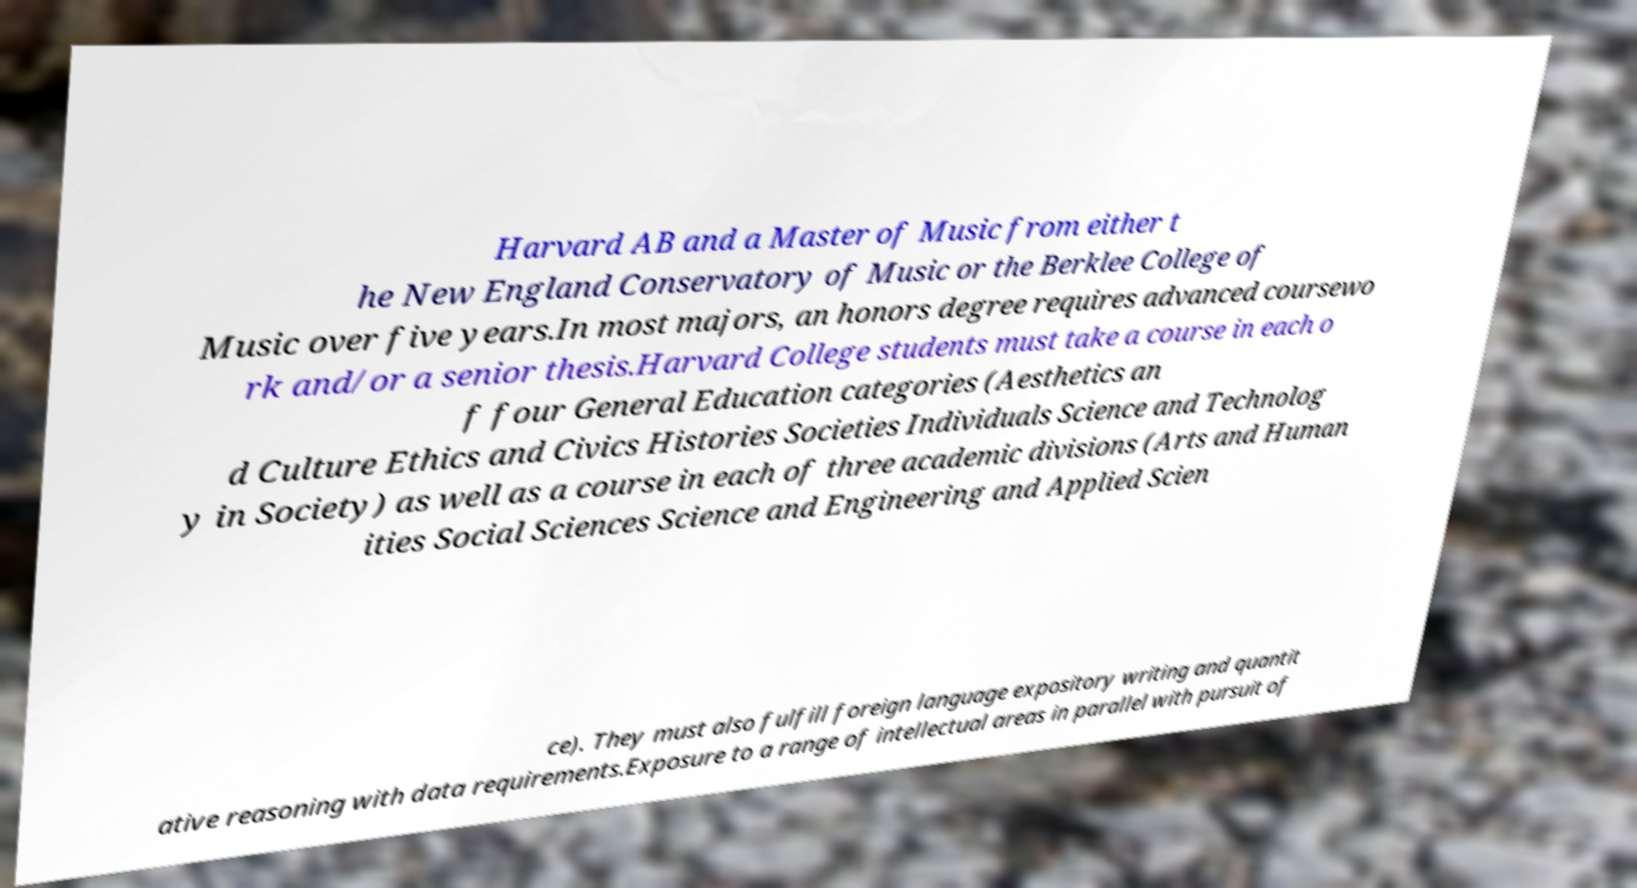Please identify and transcribe the text found in this image. Harvard AB and a Master of Music from either t he New England Conservatory of Music or the Berklee College of Music over five years.In most majors, an honors degree requires advanced coursewo rk and/or a senior thesis.Harvard College students must take a course in each o f four General Education categories (Aesthetics an d Culture Ethics and Civics Histories Societies Individuals Science and Technolog y in Society) as well as a course in each of three academic divisions (Arts and Human ities Social Sciences Science and Engineering and Applied Scien ce). They must also fulfill foreign language expository writing and quantit ative reasoning with data requirements.Exposure to a range of intellectual areas in parallel with pursuit of 